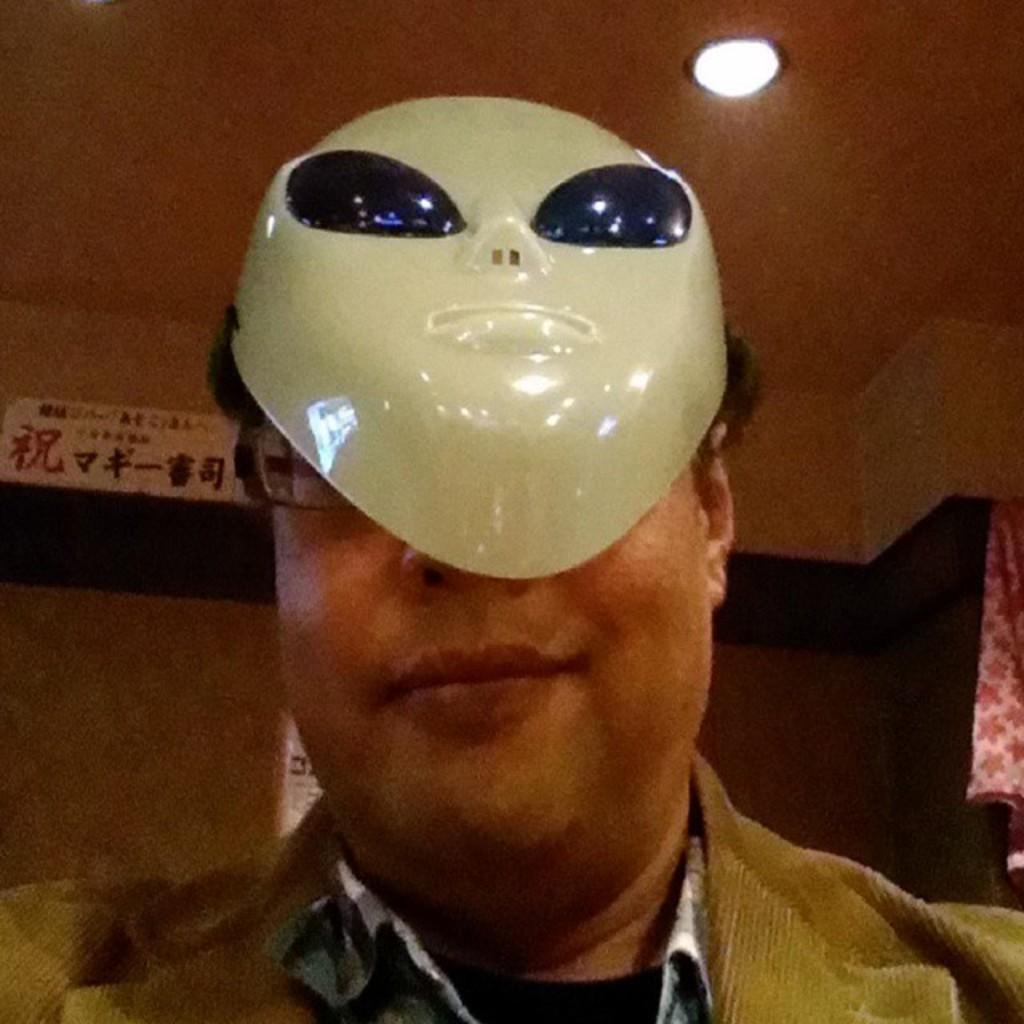Can you describe this image briefly? In this image, we can see a person wearing clothes and mask. There is a light at the top of the image. There is a cloth on the right side of the image. 